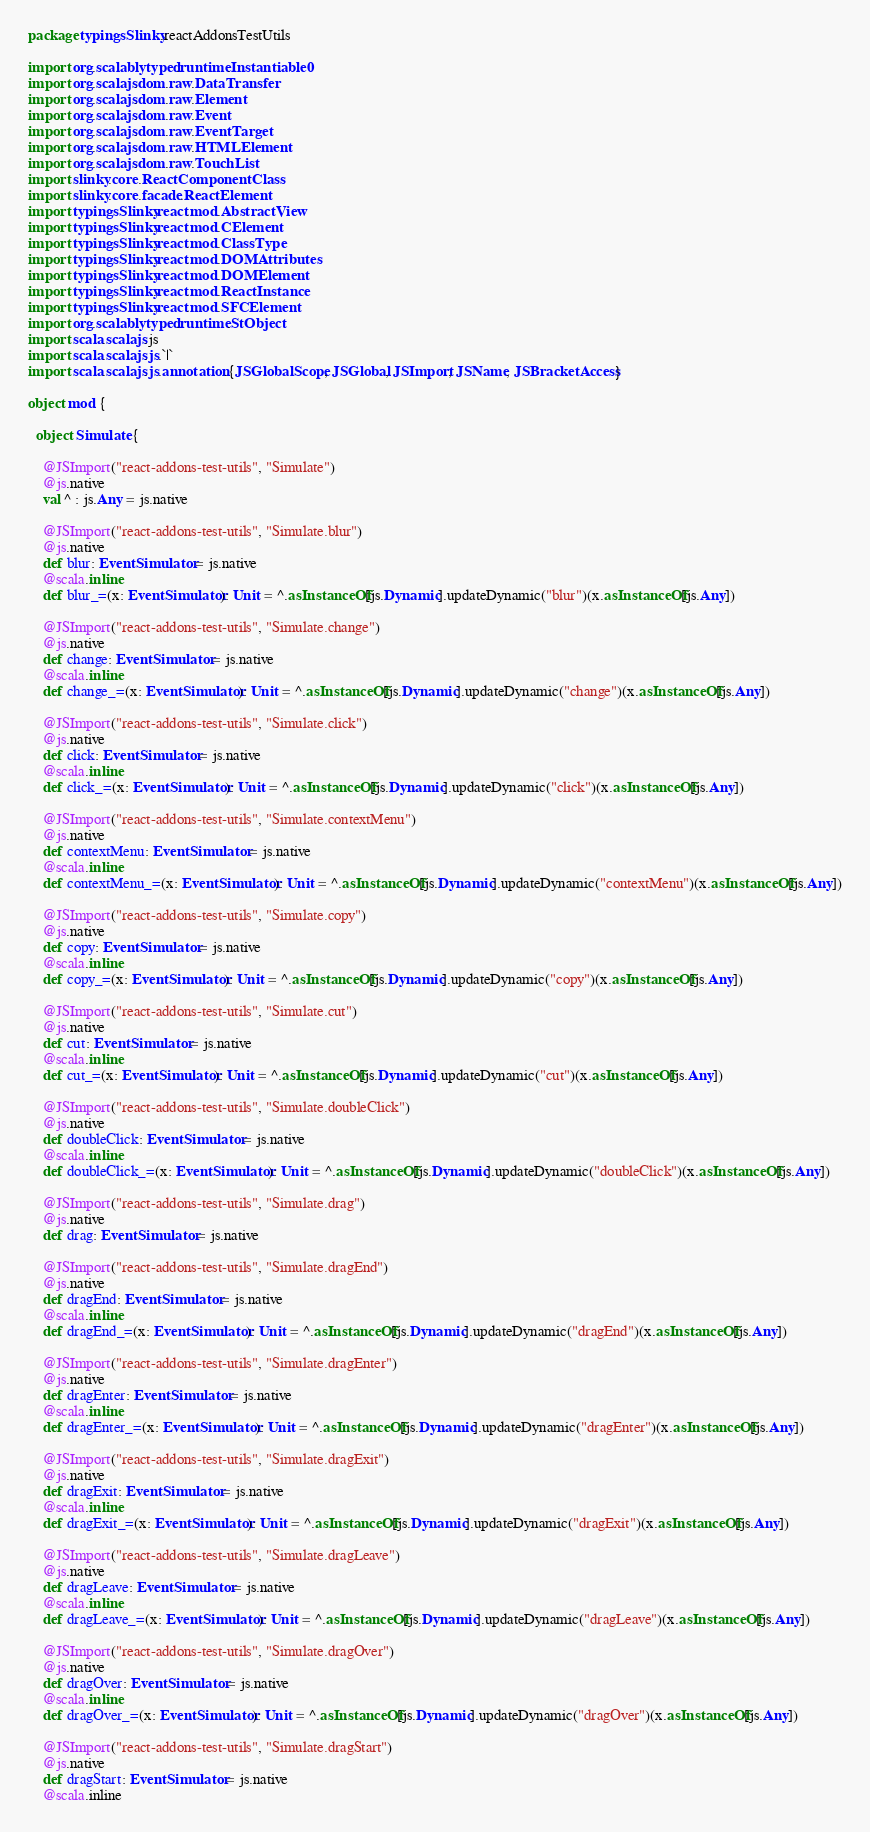<code> <loc_0><loc_0><loc_500><loc_500><_Scala_>package typingsSlinky.reactAddonsTestUtils

import org.scalablytyped.runtime.Instantiable0
import org.scalajs.dom.raw.DataTransfer
import org.scalajs.dom.raw.Element
import org.scalajs.dom.raw.Event
import org.scalajs.dom.raw.EventTarget
import org.scalajs.dom.raw.HTMLElement
import org.scalajs.dom.raw.TouchList
import slinky.core.ReactComponentClass
import slinky.core.facade.ReactElement
import typingsSlinky.react.mod.AbstractView
import typingsSlinky.react.mod.CElement
import typingsSlinky.react.mod.ClassType
import typingsSlinky.react.mod.DOMAttributes
import typingsSlinky.react.mod.DOMElement
import typingsSlinky.react.mod.ReactInstance
import typingsSlinky.react.mod.SFCElement
import org.scalablytyped.runtime.StObject
import scala.scalajs.js
import scala.scalajs.js.`|`
import scala.scalajs.js.annotation.{JSGlobalScope, JSGlobal, JSImport, JSName, JSBracketAccess}

object mod {
  
  object Simulate {
    
    @JSImport("react-addons-test-utils", "Simulate")
    @js.native
    val ^ : js.Any = js.native
    
    @JSImport("react-addons-test-utils", "Simulate.blur")
    @js.native
    def blur: EventSimulator = js.native
    @scala.inline
    def blur_=(x: EventSimulator): Unit = ^.asInstanceOf[js.Dynamic].updateDynamic("blur")(x.asInstanceOf[js.Any])
    
    @JSImport("react-addons-test-utils", "Simulate.change")
    @js.native
    def change: EventSimulator = js.native
    @scala.inline
    def change_=(x: EventSimulator): Unit = ^.asInstanceOf[js.Dynamic].updateDynamic("change")(x.asInstanceOf[js.Any])
    
    @JSImport("react-addons-test-utils", "Simulate.click")
    @js.native
    def click: EventSimulator = js.native
    @scala.inline
    def click_=(x: EventSimulator): Unit = ^.asInstanceOf[js.Dynamic].updateDynamic("click")(x.asInstanceOf[js.Any])
    
    @JSImport("react-addons-test-utils", "Simulate.contextMenu")
    @js.native
    def contextMenu: EventSimulator = js.native
    @scala.inline
    def contextMenu_=(x: EventSimulator): Unit = ^.asInstanceOf[js.Dynamic].updateDynamic("contextMenu")(x.asInstanceOf[js.Any])
    
    @JSImport("react-addons-test-utils", "Simulate.copy")
    @js.native
    def copy: EventSimulator = js.native
    @scala.inline
    def copy_=(x: EventSimulator): Unit = ^.asInstanceOf[js.Dynamic].updateDynamic("copy")(x.asInstanceOf[js.Any])
    
    @JSImport("react-addons-test-utils", "Simulate.cut")
    @js.native
    def cut: EventSimulator = js.native
    @scala.inline
    def cut_=(x: EventSimulator): Unit = ^.asInstanceOf[js.Dynamic].updateDynamic("cut")(x.asInstanceOf[js.Any])
    
    @JSImport("react-addons-test-utils", "Simulate.doubleClick")
    @js.native
    def doubleClick: EventSimulator = js.native
    @scala.inline
    def doubleClick_=(x: EventSimulator): Unit = ^.asInstanceOf[js.Dynamic].updateDynamic("doubleClick")(x.asInstanceOf[js.Any])
    
    @JSImport("react-addons-test-utils", "Simulate.drag")
    @js.native
    def drag: EventSimulator = js.native
    
    @JSImport("react-addons-test-utils", "Simulate.dragEnd")
    @js.native
    def dragEnd: EventSimulator = js.native
    @scala.inline
    def dragEnd_=(x: EventSimulator): Unit = ^.asInstanceOf[js.Dynamic].updateDynamic("dragEnd")(x.asInstanceOf[js.Any])
    
    @JSImport("react-addons-test-utils", "Simulate.dragEnter")
    @js.native
    def dragEnter: EventSimulator = js.native
    @scala.inline
    def dragEnter_=(x: EventSimulator): Unit = ^.asInstanceOf[js.Dynamic].updateDynamic("dragEnter")(x.asInstanceOf[js.Any])
    
    @JSImport("react-addons-test-utils", "Simulate.dragExit")
    @js.native
    def dragExit: EventSimulator = js.native
    @scala.inline
    def dragExit_=(x: EventSimulator): Unit = ^.asInstanceOf[js.Dynamic].updateDynamic("dragExit")(x.asInstanceOf[js.Any])
    
    @JSImport("react-addons-test-utils", "Simulate.dragLeave")
    @js.native
    def dragLeave: EventSimulator = js.native
    @scala.inline
    def dragLeave_=(x: EventSimulator): Unit = ^.asInstanceOf[js.Dynamic].updateDynamic("dragLeave")(x.asInstanceOf[js.Any])
    
    @JSImport("react-addons-test-utils", "Simulate.dragOver")
    @js.native
    def dragOver: EventSimulator = js.native
    @scala.inline
    def dragOver_=(x: EventSimulator): Unit = ^.asInstanceOf[js.Dynamic].updateDynamic("dragOver")(x.asInstanceOf[js.Any])
    
    @JSImport("react-addons-test-utils", "Simulate.dragStart")
    @js.native
    def dragStart: EventSimulator = js.native
    @scala.inline</code> 